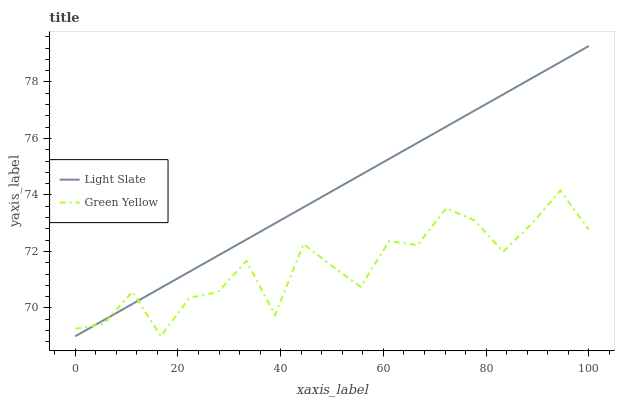Does Green Yellow have the minimum area under the curve?
Answer yes or no. Yes. Does Light Slate have the maximum area under the curve?
Answer yes or no. Yes. Does Green Yellow have the maximum area under the curve?
Answer yes or no. No. Is Light Slate the smoothest?
Answer yes or no. Yes. Is Green Yellow the roughest?
Answer yes or no. Yes. Is Green Yellow the smoothest?
Answer yes or no. No. Does Light Slate have the lowest value?
Answer yes or no. Yes. Does Light Slate have the highest value?
Answer yes or no. Yes. Does Green Yellow have the highest value?
Answer yes or no. No. Does Green Yellow intersect Light Slate?
Answer yes or no. Yes. Is Green Yellow less than Light Slate?
Answer yes or no. No. Is Green Yellow greater than Light Slate?
Answer yes or no. No. 